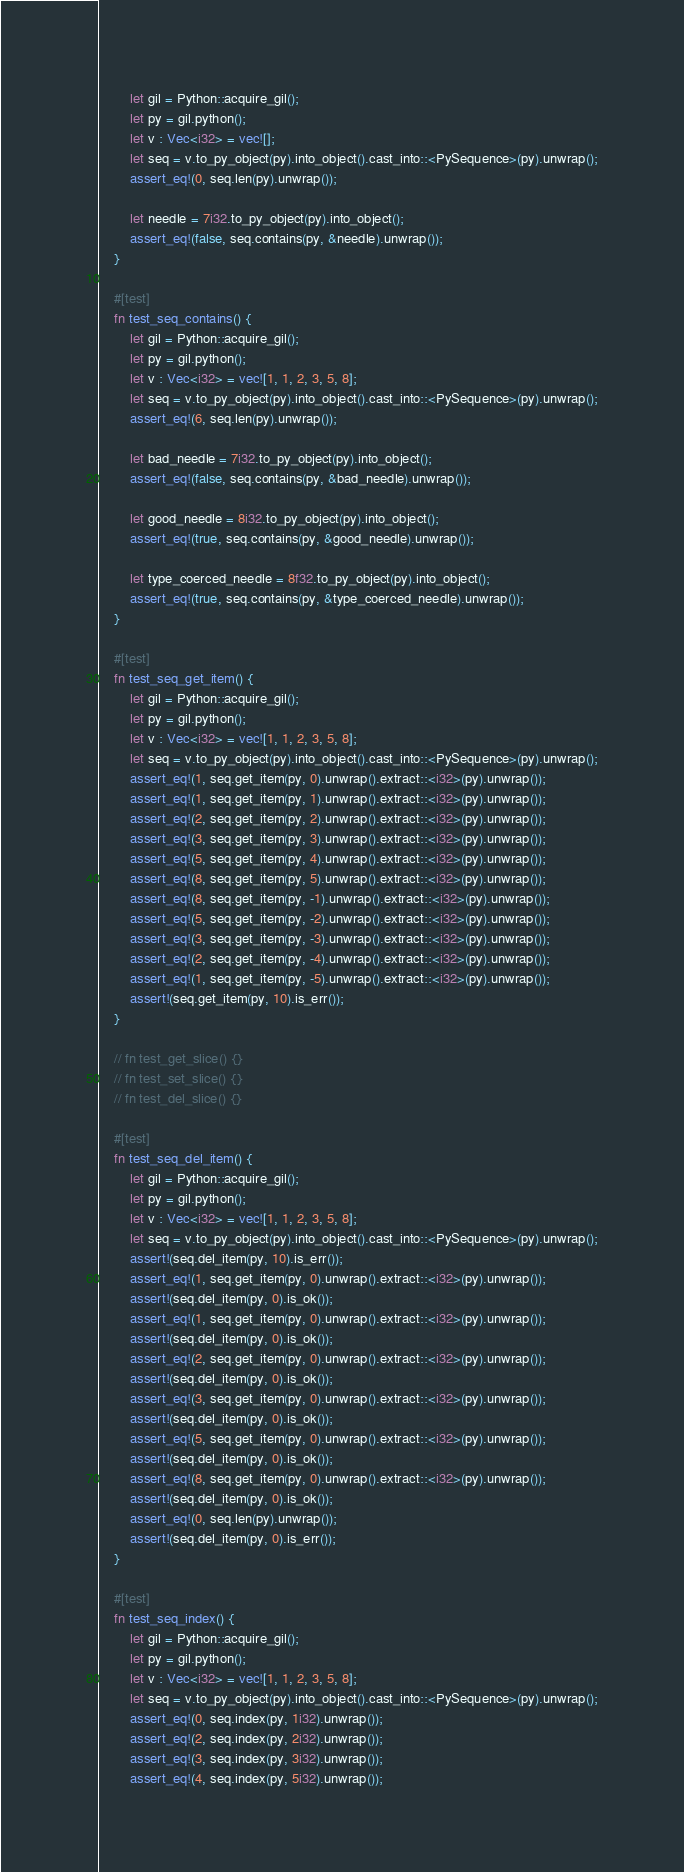<code> <loc_0><loc_0><loc_500><loc_500><_Rust_>        let gil = Python::acquire_gil();
        let py = gil.python();
        let v : Vec<i32> = vec![];
        let seq = v.to_py_object(py).into_object().cast_into::<PySequence>(py).unwrap();
        assert_eq!(0, seq.len(py).unwrap());

        let needle = 7i32.to_py_object(py).into_object();
        assert_eq!(false, seq.contains(py, &needle).unwrap());
    }

    #[test]
    fn test_seq_contains() {
        let gil = Python::acquire_gil();
        let py = gil.python();
        let v : Vec<i32> = vec![1, 1, 2, 3, 5, 8];
        let seq = v.to_py_object(py).into_object().cast_into::<PySequence>(py).unwrap();
        assert_eq!(6, seq.len(py).unwrap());

        let bad_needle = 7i32.to_py_object(py).into_object();
        assert_eq!(false, seq.contains(py, &bad_needle).unwrap());

        let good_needle = 8i32.to_py_object(py).into_object();
        assert_eq!(true, seq.contains(py, &good_needle).unwrap());

        let type_coerced_needle = 8f32.to_py_object(py).into_object();
        assert_eq!(true, seq.contains(py, &type_coerced_needle).unwrap());
    }

    #[test]
    fn test_seq_get_item() {
        let gil = Python::acquire_gil();
        let py = gil.python();
        let v : Vec<i32> = vec![1, 1, 2, 3, 5, 8];
        let seq = v.to_py_object(py).into_object().cast_into::<PySequence>(py).unwrap();
        assert_eq!(1, seq.get_item(py, 0).unwrap().extract::<i32>(py).unwrap());
        assert_eq!(1, seq.get_item(py, 1).unwrap().extract::<i32>(py).unwrap());
        assert_eq!(2, seq.get_item(py, 2).unwrap().extract::<i32>(py).unwrap());
        assert_eq!(3, seq.get_item(py, 3).unwrap().extract::<i32>(py).unwrap());
        assert_eq!(5, seq.get_item(py, 4).unwrap().extract::<i32>(py).unwrap());
        assert_eq!(8, seq.get_item(py, 5).unwrap().extract::<i32>(py).unwrap());
        assert_eq!(8, seq.get_item(py, -1).unwrap().extract::<i32>(py).unwrap());
        assert_eq!(5, seq.get_item(py, -2).unwrap().extract::<i32>(py).unwrap());
        assert_eq!(3, seq.get_item(py, -3).unwrap().extract::<i32>(py).unwrap());
        assert_eq!(2, seq.get_item(py, -4).unwrap().extract::<i32>(py).unwrap());
        assert_eq!(1, seq.get_item(py, -5).unwrap().extract::<i32>(py).unwrap());
        assert!(seq.get_item(py, 10).is_err());
    }

    // fn test_get_slice() {}
    // fn test_set_slice() {}
    // fn test_del_slice() {}

    #[test]
    fn test_seq_del_item() {
        let gil = Python::acquire_gil();
        let py = gil.python();
        let v : Vec<i32> = vec![1, 1, 2, 3, 5, 8];
        let seq = v.to_py_object(py).into_object().cast_into::<PySequence>(py).unwrap();
        assert!(seq.del_item(py, 10).is_err());
        assert_eq!(1, seq.get_item(py, 0).unwrap().extract::<i32>(py).unwrap());
        assert!(seq.del_item(py, 0).is_ok());
        assert_eq!(1, seq.get_item(py, 0).unwrap().extract::<i32>(py).unwrap());
        assert!(seq.del_item(py, 0).is_ok());
        assert_eq!(2, seq.get_item(py, 0).unwrap().extract::<i32>(py).unwrap());
        assert!(seq.del_item(py, 0).is_ok());
        assert_eq!(3, seq.get_item(py, 0).unwrap().extract::<i32>(py).unwrap());
        assert!(seq.del_item(py, 0).is_ok());
        assert_eq!(5, seq.get_item(py, 0).unwrap().extract::<i32>(py).unwrap());
        assert!(seq.del_item(py, 0).is_ok());
        assert_eq!(8, seq.get_item(py, 0).unwrap().extract::<i32>(py).unwrap());
        assert!(seq.del_item(py, 0).is_ok());
        assert_eq!(0, seq.len(py).unwrap());
        assert!(seq.del_item(py, 0).is_err());
    }

    #[test]
    fn test_seq_index() {
        let gil = Python::acquire_gil();
        let py = gil.python();
        let v : Vec<i32> = vec![1, 1, 2, 3, 5, 8];
        let seq = v.to_py_object(py).into_object().cast_into::<PySequence>(py).unwrap();
        assert_eq!(0, seq.index(py, 1i32).unwrap());
        assert_eq!(2, seq.index(py, 2i32).unwrap());
        assert_eq!(3, seq.index(py, 3i32).unwrap());
        assert_eq!(4, seq.index(py, 5i32).unwrap());</code> 